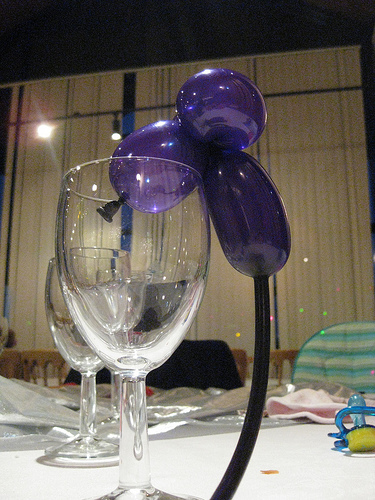<image>
Is the balloon on the glass? Yes. Looking at the image, I can see the balloon is positioned on top of the glass, with the glass providing support. Is there a glass in the balloon? No. The glass is not contained within the balloon. These objects have a different spatial relationship. Is the balloon above the wineglass? Yes. The balloon is positioned above the wineglass in the vertical space, higher up in the scene. 